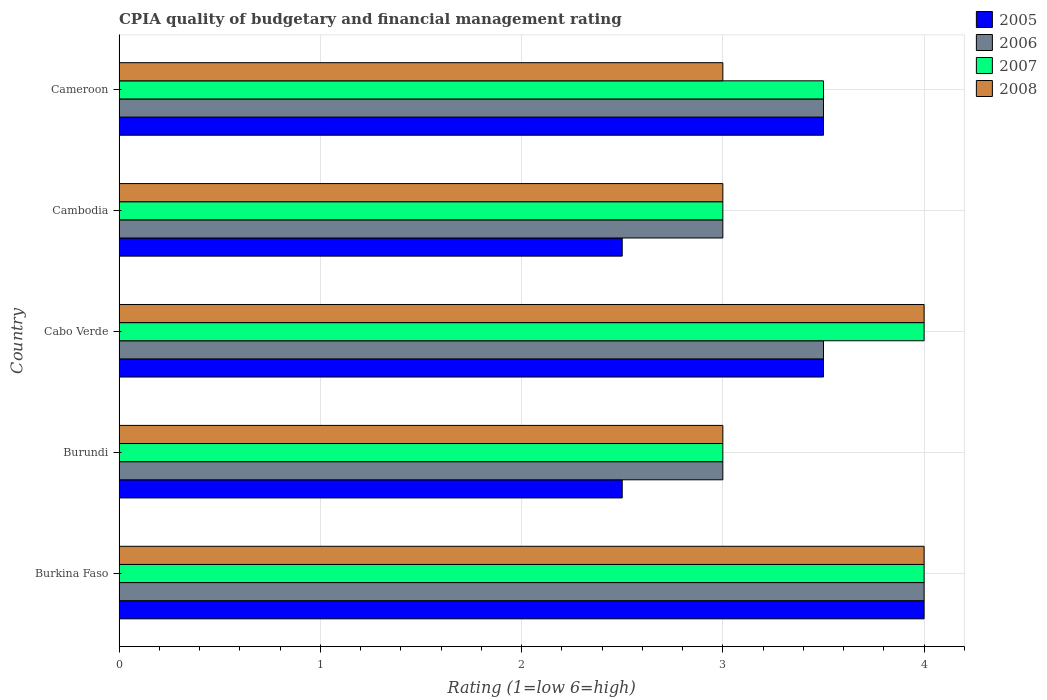How many different coloured bars are there?
Your answer should be very brief. 4. How many bars are there on the 2nd tick from the top?
Keep it short and to the point. 4. How many bars are there on the 1st tick from the bottom?
Offer a very short reply. 4. What is the label of the 2nd group of bars from the top?
Provide a succinct answer. Cambodia. What is the CPIA rating in 2007 in Cameroon?
Offer a very short reply. 3.5. Across all countries, what is the minimum CPIA rating in 2005?
Your answer should be very brief. 2.5. In which country was the CPIA rating in 2006 maximum?
Ensure brevity in your answer.  Burkina Faso. In which country was the CPIA rating in 2007 minimum?
Ensure brevity in your answer.  Burundi. What is the difference between the CPIA rating in 2007 in Cabo Verde and the CPIA rating in 2005 in Burkina Faso?
Make the answer very short. 0. What is the average CPIA rating in 2008 per country?
Offer a very short reply. 3.4. In how many countries, is the CPIA rating in 2006 greater than 0.8 ?
Give a very brief answer. 5. What is the ratio of the CPIA rating in 2007 in Burundi to that in Cameroon?
Offer a terse response. 0.86. Is the difference between the CPIA rating in 2006 in Burundi and Cambodia greater than the difference between the CPIA rating in 2008 in Burundi and Cambodia?
Give a very brief answer. No. What is the difference between the highest and the second highest CPIA rating in 2006?
Your answer should be very brief. 0.5. Is it the case that in every country, the sum of the CPIA rating in 2006 and CPIA rating in 2007 is greater than the sum of CPIA rating in 2005 and CPIA rating in 2008?
Give a very brief answer. No. What does the 1st bar from the bottom in Burkina Faso represents?
Your response must be concise. 2005. Is it the case that in every country, the sum of the CPIA rating in 2005 and CPIA rating in 2007 is greater than the CPIA rating in 2008?
Ensure brevity in your answer.  Yes. Does the graph contain grids?
Keep it short and to the point. Yes. How many legend labels are there?
Keep it short and to the point. 4. What is the title of the graph?
Keep it short and to the point. CPIA quality of budgetary and financial management rating. What is the Rating (1=low 6=high) of 2005 in Burkina Faso?
Make the answer very short. 4. What is the Rating (1=low 6=high) of 2006 in Burkina Faso?
Give a very brief answer. 4. What is the Rating (1=low 6=high) in 2007 in Burkina Faso?
Your answer should be compact. 4. What is the Rating (1=low 6=high) in 2008 in Burkina Faso?
Ensure brevity in your answer.  4. What is the Rating (1=low 6=high) of 2005 in Burundi?
Keep it short and to the point. 2.5. What is the Rating (1=low 6=high) of 2006 in Burundi?
Offer a very short reply. 3. What is the Rating (1=low 6=high) of 2007 in Cabo Verde?
Your answer should be very brief. 4. What is the Rating (1=low 6=high) in 2008 in Cabo Verde?
Your answer should be compact. 4. What is the Rating (1=low 6=high) of 2008 in Cambodia?
Offer a terse response. 3. What is the Rating (1=low 6=high) of 2005 in Cameroon?
Provide a short and direct response. 3.5. Across all countries, what is the maximum Rating (1=low 6=high) of 2005?
Provide a short and direct response. 4. Across all countries, what is the maximum Rating (1=low 6=high) in 2007?
Your response must be concise. 4. Across all countries, what is the maximum Rating (1=low 6=high) in 2008?
Your answer should be very brief. 4. What is the difference between the Rating (1=low 6=high) in 2005 in Burkina Faso and that in Burundi?
Offer a terse response. 1.5. What is the difference between the Rating (1=low 6=high) in 2007 in Burkina Faso and that in Burundi?
Ensure brevity in your answer.  1. What is the difference between the Rating (1=low 6=high) in 2008 in Burkina Faso and that in Burundi?
Keep it short and to the point. 1. What is the difference between the Rating (1=low 6=high) in 2006 in Burkina Faso and that in Cabo Verde?
Your response must be concise. 0.5. What is the difference between the Rating (1=low 6=high) in 2008 in Burkina Faso and that in Cabo Verde?
Provide a succinct answer. 0. What is the difference between the Rating (1=low 6=high) in 2005 in Burkina Faso and that in Cambodia?
Give a very brief answer. 1.5. What is the difference between the Rating (1=low 6=high) in 2006 in Burkina Faso and that in Cambodia?
Offer a terse response. 1. What is the difference between the Rating (1=low 6=high) in 2007 in Burkina Faso and that in Cambodia?
Offer a very short reply. 1. What is the difference between the Rating (1=low 6=high) in 2008 in Burkina Faso and that in Cambodia?
Ensure brevity in your answer.  1. What is the difference between the Rating (1=low 6=high) of 2005 in Burkina Faso and that in Cameroon?
Provide a short and direct response. 0.5. What is the difference between the Rating (1=low 6=high) of 2006 in Burkina Faso and that in Cameroon?
Provide a short and direct response. 0.5. What is the difference between the Rating (1=low 6=high) in 2007 in Burkina Faso and that in Cameroon?
Give a very brief answer. 0.5. What is the difference between the Rating (1=low 6=high) in 2008 in Burkina Faso and that in Cameroon?
Your answer should be compact. 1. What is the difference between the Rating (1=low 6=high) of 2008 in Burundi and that in Cabo Verde?
Offer a very short reply. -1. What is the difference between the Rating (1=low 6=high) in 2006 in Burundi and that in Cambodia?
Offer a very short reply. 0. What is the difference between the Rating (1=low 6=high) in 2005 in Burundi and that in Cameroon?
Keep it short and to the point. -1. What is the difference between the Rating (1=low 6=high) of 2008 in Burundi and that in Cameroon?
Keep it short and to the point. 0. What is the difference between the Rating (1=low 6=high) of 2005 in Cabo Verde and that in Cambodia?
Your answer should be compact. 1. What is the difference between the Rating (1=low 6=high) in 2006 in Cabo Verde and that in Cambodia?
Your response must be concise. 0.5. What is the difference between the Rating (1=low 6=high) of 2007 in Cabo Verde and that in Cambodia?
Give a very brief answer. 1. What is the difference between the Rating (1=low 6=high) in 2008 in Cabo Verde and that in Cambodia?
Provide a short and direct response. 1. What is the difference between the Rating (1=low 6=high) in 2006 in Cabo Verde and that in Cameroon?
Ensure brevity in your answer.  0. What is the difference between the Rating (1=low 6=high) of 2007 in Cabo Verde and that in Cameroon?
Ensure brevity in your answer.  0.5. What is the difference between the Rating (1=low 6=high) of 2005 in Cambodia and that in Cameroon?
Offer a terse response. -1. What is the difference between the Rating (1=low 6=high) in 2007 in Cambodia and that in Cameroon?
Make the answer very short. -0.5. What is the difference between the Rating (1=low 6=high) of 2005 in Burkina Faso and the Rating (1=low 6=high) of 2006 in Burundi?
Ensure brevity in your answer.  1. What is the difference between the Rating (1=low 6=high) of 2005 in Burkina Faso and the Rating (1=low 6=high) of 2007 in Burundi?
Offer a very short reply. 1. What is the difference between the Rating (1=low 6=high) of 2006 in Burkina Faso and the Rating (1=low 6=high) of 2008 in Burundi?
Keep it short and to the point. 1. What is the difference between the Rating (1=low 6=high) of 2007 in Burkina Faso and the Rating (1=low 6=high) of 2008 in Burundi?
Your answer should be very brief. 1. What is the difference between the Rating (1=low 6=high) of 2005 in Burkina Faso and the Rating (1=low 6=high) of 2006 in Cabo Verde?
Provide a short and direct response. 0.5. What is the difference between the Rating (1=low 6=high) of 2007 in Burkina Faso and the Rating (1=low 6=high) of 2008 in Cabo Verde?
Offer a terse response. 0. What is the difference between the Rating (1=low 6=high) of 2007 in Burkina Faso and the Rating (1=low 6=high) of 2008 in Cambodia?
Give a very brief answer. 1. What is the difference between the Rating (1=low 6=high) in 2005 in Burkina Faso and the Rating (1=low 6=high) in 2006 in Cameroon?
Your answer should be compact. 0.5. What is the difference between the Rating (1=low 6=high) of 2005 in Burkina Faso and the Rating (1=low 6=high) of 2008 in Cameroon?
Your answer should be compact. 1. What is the difference between the Rating (1=low 6=high) in 2006 in Burkina Faso and the Rating (1=low 6=high) in 2007 in Cameroon?
Your answer should be very brief. 0.5. What is the difference between the Rating (1=low 6=high) in 2007 in Burkina Faso and the Rating (1=low 6=high) in 2008 in Cameroon?
Keep it short and to the point. 1. What is the difference between the Rating (1=low 6=high) in 2005 in Burundi and the Rating (1=low 6=high) in 2007 in Cabo Verde?
Your answer should be very brief. -1.5. What is the difference between the Rating (1=low 6=high) of 2006 in Burundi and the Rating (1=low 6=high) of 2007 in Cabo Verde?
Keep it short and to the point. -1. What is the difference between the Rating (1=low 6=high) in 2006 in Burundi and the Rating (1=low 6=high) in 2008 in Cabo Verde?
Your answer should be compact. -1. What is the difference between the Rating (1=low 6=high) in 2007 in Burundi and the Rating (1=low 6=high) in 2008 in Cabo Verde?
Keep it short and to the point. -1. What is the difference between the Rating (1=low 6=high) of 2005 in Burundi and the Rating (1=low 6=high) of 2006 in Cambodia?
Provide a short and direct response. -0.5. What is the difference between the Rating (1=low 6=high) in 2005 in Burundi and the Rating (1=low 6=high) in 2008 in Cambodia?
Offer a very short reply. -0.5. What is the difference between the Rating (1=low 6=high) of 2006 in Burundi and the Rating (1=low 6=high) of 2007 in Cambodia?
Make the answer very short. 0. What is the difference between the Rating (1=low 6=high) in 2006 in Burundi and the Rating (1=low 6=high) in 2008 in Cambodia?
Your answer should be very brief. 0. What is the difference between the Rating (1=low 6=high) of 2005 in Burundi and the Rating (1=low 6=high) of 2006 in Cameroon?
Give a very brief answer. -1. What is the difference between the Rating (1=low 6=high) in 2005 in Burundi and the Rating (1=low 6=high) in 2008 in Cameroon?
Your response must be concise. -0.5. What is the difference between the Rating (1=low 6=high) in 2005 in Cabo Verde and the Rating (1=low 6=high) in 2006 in Cambodia?
Provide a short and direct response. 0.5. What is the difference between the Rating (1=low 6=high) of 2005 in Cabo Verde and the Rating (1=low 6=high) of 2008 in Cambodia?
Your answer should be very brief. 0.5. What is the difference between the Rating (1=low 6=high) in 2006 in Cabo Verde and the Rating (1=low 6=high) in 2007 in Cambodia?
Your answer should be very brief. 0.5. What is the difference between the Rating (1=low 6=high) in 2005 in Cabo Verde and the Rating (1=low 6=high) in 2006 in Cameroon?
Offer a terse response. 0. What is the difference between the Rating (1=low 6=high) of 2006 in Cabo Verde and the Rating (1=low 6=high) of 2008 in Cameroon?
Give a very brief answer. 0.5. What is the difference between the Rating (1=low 6=high) of 2007 in Cabo Verde and the Rating (1=low 6=high) of 2008 in Cameroon?
Your answer should be very brief. 1. What is the difference between the Rating (1=low 6=high) in 2006 in Cambodia and the Rating (1=low 6=high) in 2007 in Cameroon?
Ensure brevity in your answer.  -0.5. What is the average Rating (1=low 6=high) in 2005 per country?
Offer a terse response. 3.2. What is the average Rating (1=low 6=high) of 2007 per country?
Your response must be concise. 3.5. What is the difference between the Rating (1=low 6=high) in 2005 and Rating (1=low 6=high) in 2008 in Burkina Faso?
Your answer should be compact. 0. What is the difference between the Rating (1=low 6=high) in 2006 and Rating (1=low 6=high) in 2008 in Burkina Faso?
Offer a terse response. 0. What is the difference between the Rating (1=low 6=high) of 2007 and Rating (1=low 6=high) of 2008 in Burkina Faso?
Provide a short and direct response. 0. What is the difference between the Rating (1=low 6=high) of 2005 and Rating (1=low 6=high) of 2007 in Burundi?
Your answer should be compact. -0.5. What is the difference between the Rating (1=low 6=high) in 2005 and Rating (1=low 6=high) in 2006 in Cabo Verde?
Provide a succinct answer. 0. What is the difference between the Rating (1=low 6=high) in 2005 and Rating (1=low 6=high) in 2008 in Cabo Verde?
Offer a terse response. -0.5. What is the difference between the Rating (1=low 6=high) of 2007 and Rating (1=low 6=high) of 2008 in Cabo Verde?
Your answer should be very brief. 0. What is the difference between the Rating (1=low 6=high) of 2007 and Rating (1=low 6=high) of 2008 in Cambodia?
Keep it short and to the point. 0. What is the difference between the Rating (1=low 6=high) in 2006 and Rating (1=low 6=high) in 2008 in Cameroon?
Provide a short and direct response. 0.5. What is the ratio of the Rating (1=low 6=high) in 2005 in Burkina Faso to that in Burundi?
Offer a very short reply. 1.6. What is the ratio of the Rating (1=low 6=high) in 2007 in Burkina Faso to that in Burundi?
Your answer should be compact. 1.33. What is the ratio of the Rating (1=low 6=high) in 2007 in Burkina Faso to that in Cabo Verde?
Your answer should be very brief. 1. What is the ratio of the Rating (1=low 6=high) in 2008 in Burkina Faso to that in Cabo Verde?
Provide a succinct answer. 1. What is the ratio of the Rating (1=low 6=high) in 2007 in Burkina Faso to that in Cambodia?
Make the answer very short. 1.33. What is the ratio of the Rating (1=low 6=high) in 2007 in Burkina Faso to that in Cameroon?
Make the answer very short. 1.14. What is the ratio of the Rating (1=low 6=high) in 2008 in Burkina Faso to that in Cameroon?
Offer a terse response. 1.33. What is the ratio of the Rating (1=low 6=high) of 2006 in Burundi to that in Cabo Verde?
Keep it short and to the point. 0.86. What is the ratio of the Rating (1=low 6=high) of 2007 in Burundi to that in Cabo Verde?
Provide a short and direct response. 0.75. What is the ratio of the Rating (1=low 6=high) of 2008 in Burundi to that in Cabo Verde?
Give a very brief answer. 0.75. What is the ratio of the Rating (1=low 6=high) of 2005 in Burundi to that in Cambodia?
Ensure brevity in your answer.  1. What is the ratio of the Rating (1=low 6=high) in 2008 in Burundi to that in Cambodia?
Keep it short and to the point. 1. What is the ratio of the Rating (1=low 6=high) of 2007 in Burundi to that in Cameroon?
Your answer should be compact. 0.86. What is the ratio of the Rating (1=low 6=high) of 2006 in Cabo Verde to that in Cambodia?
Give a very brief answer. 1.17. What is the ratio of the Rating (1=low 6=high) of 2007 in Cabo Verde to that in Cambodia?
Your response must be concise. 1.33. What is the ratio of the Rating (1=low 6=high) in 2005 in Cabo Verde to that in Cameroon?
Provide a succinct answer. 1. What is the ratio of the Rating (1=low 6=high) of 2006 in Cabo Verde to that in Cameroon?
Give a very brief answer. 1. What is the ratio of the Rating (1=low 6=high) in 2007 in Cabo Verde to that in Cameroon?
Your response must be concise. 1.14. What is the ratio of the Rating (1=low 6=high) in 2005 in Cambodia to that in Cameroon?
Keep it short and to the point. 0.71. What is the ratio of the Rating (1=low 6=high) of 2006 in Cambodia to that in Cameroon?
Your answer should be compact. 0.86. What is the ratio of the Rating (1=low 6=high) in 2007 in Cambodia to that in Cameroon?
Your response must be concise. 0.86. What is the ratio of the Rating (1=low 6=high) in 2008 in Cambodia to that in Cameroon?
Ensure brevity in your answer.  1. What is the difference between the highest and the second highest Rating (1=low 6=high) of 2006?
Make the answer very short. 0.5. What is the difference between the highest and the second highest Rating (1=low 6=high) in 2007?
Give a very brief answer. 0. What is the difference between the highest and the second highest Rating (1=low 6=high) in 2008?
Your answer should be very brief. 0. What is the difference between the highest and the lowest Rating (1=low 6=high) in 2005?
Ensure brevity in your answer.  1.5. What is the difference between the highest and the lowest Rating (1=low 6=high) of 2007?
Offer a terse response. 1. What is the difference between the highest and the lowest Rating (1=low 6=high) of 2008?
Make the answer very short. 1. 